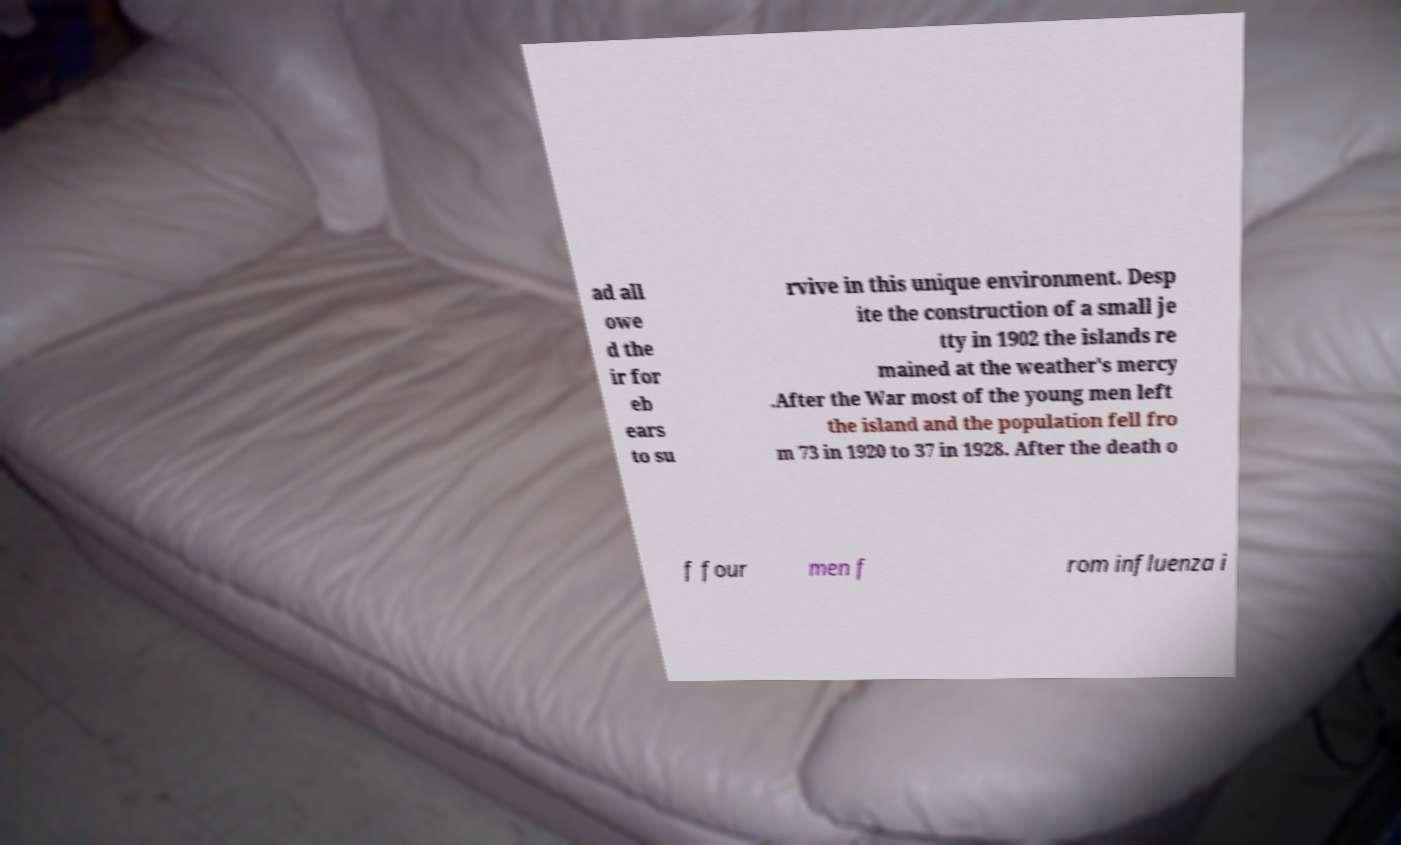Can you accurately transcribe the text from the provided image for me? ad all owe d the ir for eb ears to su rvive in this unique environment. Desp ite the construction of a small je tty in 1902 the islands re mained at the weather's mercy .After the War most of the young men left the island and the population fell fro m 73 in 1920 to 37 in 1928. After the death o f four men f rom influenza i 